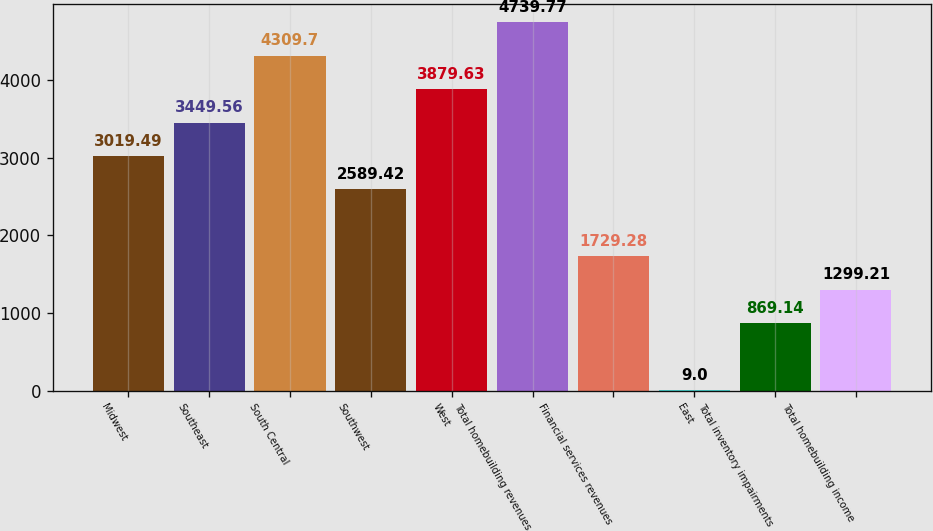Convert chart to OTSL. <chart><loc_0><loc_0><loc_500><loc_500><bar_chart><fcel>Midwest<fcel>Southeast<fcel>South Central<fcel>Southwest<fcel>West<fcel>Total homebuilding revenues<fcel>Financial services revenues<fcel>East<fcel>Total inventory impairments<fcel>Total homebuilding income<nl><fcel>3019.49<fcel>3449.56<fcel>4309.7<fcel>2589.42<fcel>3879.63<fcel>4739.77<fcel>1729.28<fcel>9<fcel>869.14<fcel>1299.21<nl></chart> 